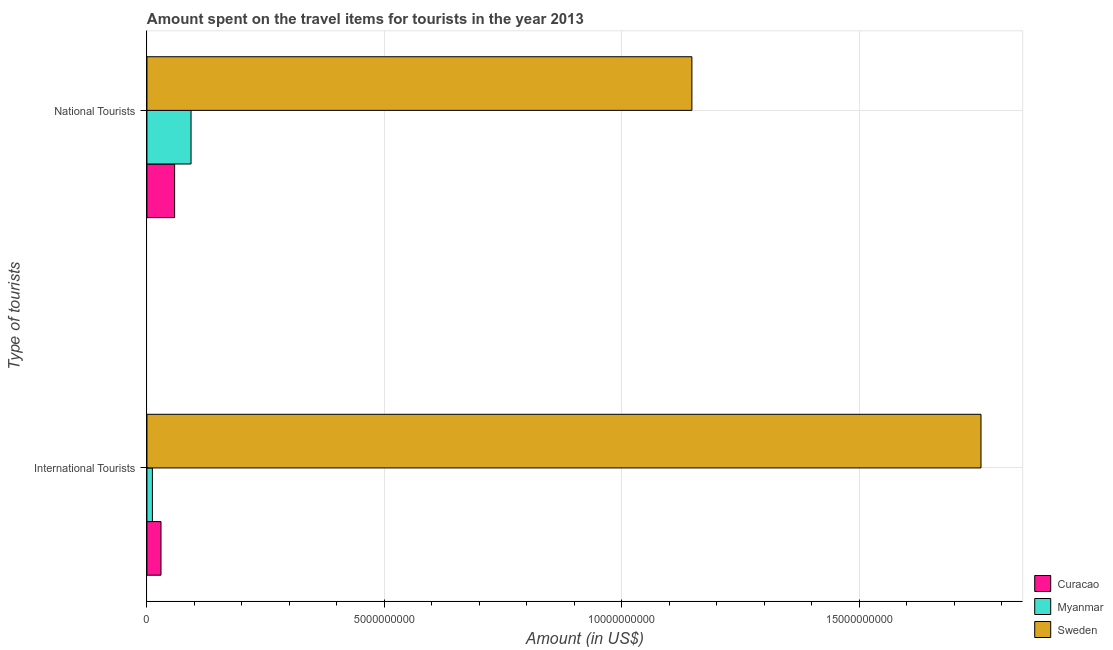How many different coloured bars are there?
Your answer should be compact. 3. Are the number of bars per tick equal to the number of legend labels?
Your answer should be compact. Yes. What is the label of the 1st group of bars from the top?
Keep it short and to the point. National Tourists. What is the amount spent on travel items of international tourists in Myanmar?
Keep it short and to the point. 1.15e+08. Across all countries, what is the maximum amount spent on travel items of international tourists?
Your answer should be very brief. 1.76e+1. Across all countries, what is the minimum amount spent on travel items of national tourists?
Give a very brief answer. 5.83e+08. In which country was the amount spent on travel items of international tourists maximum?
Give a very brief answer. Sweden. In which country was the amount spent on travel items of national tourists minimum?
Offer a terse response. Curacao. What is the total amount spent on travel items of national tourists in the graph?
Offer a terse response. 1.30e+1. What is the difference between the amount spent on travel items of international tourists in Curacao and that in Myanmar?
Give a very brief answer. 1.81e+08. What is the difference between the amount spent on travel items of national tourists in Curacao and the amount spent on travel items of international tourists in Sweden?
Offer a very short reply. -1.70e+1. What is the average amount spent on travel items of national tourists per country?
Your response must be concise. 4.33e+09. What is the difference between the amount spent on travel items of national tourists and amount spent on travel items of international tourists in Curacao?
Provide a succinct answer. 2.87e+08. In how many countries, is the amount spent on travel items of national tourists greater than 4000000000 US$?
Offer a very short reply. 1. What is the ratio of the amount spent on travel items of international tourists in Sweden to that in Myanmar?
Offer a terse response. 152.73. Is the amount spent on travel items of international tourists in Curacao less than that in Myanmar?
Your response must be concise. No. In how many countries, is the amount spent on travel items of national tourists greater than the average amount spent on travel items of national tourists taken over all countries?
Provide a short and direct response. 1. What does the 1st bar from the top in National Tourists represents?
Your response must be concise. Sweden. What does the 1st bar from the bottom in International Tourists represents?
Offer a very short reply. Curacao. Are the values on the major ticks of X-axis written in scientific E-notation?
Ensure brevity in your answer.  No. Does the graph contain any zero values?
Your answer should be very brief. No. Does the graph contain grids?
Ensure brevity in your answer.  Yes. Where does the legend appear in the graph?
Make the answer very short. Bottom right. How many legend labels are there?
Make the answer very short. 3. What is the title of the graph?
Keep it short and to the point. Amount spent on the travel items for tourists in the year 2013. Does "Small states" appear as one of the legend labels in the graph?
Give a very brief answer. No. What is the label or title of the X-axis?
Offer a very short reply. Amount (in US$). What is the label or title of the Y-axis?
Provide a succinct answer. Type of tourists. What is the Amount (in US$) of Curacao in International Tourists?
Keep it short and to the point. 2.96e+08. What is the Amount (in US$) in Myanmar in International Tourists?
Keep it short and to the point. 1.15e+08. What is the Amount (in US$) of Sweden in International Tourists?
Offer a very short reply. 1.76e+1. What is the Amount (in US$) in Curacao in National Tourists?
Provide a succinct answer. 5.83e+08. What is the Amount (in US$) in Myanmar in National Tourists?
Provide a short and direct response. 9.29e+08. What is the Amount (in US$) of Sweden in National Tourists?
Your answer should be very brief. 1.15e+1. Across all Type of tourists, what is the maximum Amount (in US$) in Curacao?
Provide a succinct answer. 5.83e+08. Across all Type of tourists, what is the maximum Amount (in US$) of Myanmar?
Ensure brevity in your answer.  9.29e+08. Across all Type of tourists, what is the maximum Amount (in US$) of Sweden?
Your answer should be very brief. 1.76e+1. Across all Type of tourists, what is the minimum Amount (in US$) in Curacao?
Provide a short and direct response. 2.96e+08. Across all Type of tourists, what is the minimum Amount (in US$) of Myanmar?
Offer a terse response. 1.15e+08. Across all Type of tourists, what is the minimum Amount (in US$) in Sweden?
Keep it short and to the point. 1.15e+1. What is the total Amount (in US$) in Curacao in the graph?
Provide a short and direct response. 8.79e+08. What is the total Amount (in US$) in Myanmar in the graph?
Give a very brief answer. 1.04e+09. What is the total Amount (in US$) of Sweden in the graph?
Provide a short and direct response. 2.90e+1. What is the difference between the Amount (in US$) of Curacao in International Tourists and that in National Tourists?
Provide a short and direct response. -2.87e+08. What is the difference between the Amount (in US$) of Myanmar in International Tourists and that in National Tourists?
Offer a very short reply. -8.14e+08. What is the difference between the Amount (in US$) in Sweden in International Tourists and that in National Tourists?
Offer a terse response. 6.09e+09. What is the difference between the Amount (in US$) in Curacao in International Tourists and the Amount (in US$) in Myanmar in National Tourists?
Your response must be concise. -6.33e+08. What is the difference between the Amount (in US$) of Curacao in International Tourists and the Amount (in US$) of Sweden in National Tourists?
Ensure brevity in your answer.  -1.12e+1. What is the difference between the Amount (in US$) in Myanmar in International Tourists and the Amount (in US$) in Sweden in National Tourists?
Offer a very short reply. -1.14e+1. What is the average Amount (in US$) of Curacao per Type of tourists?
Give a very brief answer. 4.40e+08. What is the average Amount (in US$) of Myanmar per Type of tourists?
Give a very brief answer. 5.22e+08. What is the average Amount (in US$) of Sweden per Type of tourists?
Give a very brief answer. 1.45e+1. What is the difference between the Amount (in US$) in Curacao and Amount (in US$) in Myanmar in International Tourists?
Your answer should be compact. 1.81e+08. What is the difference between the Amount (in US$) of Curacao and Amount (in US$) of Sweden in International Tourists?
Make the answer very short. -1.73e+1. What is the difference between the Amount (in US$) in Myanmar and Amount (in US$) in Sweden in International Tourists?
Your response must be concise. -1.74e+1. What is the difference between the Amount (in US$) of Curacao and Amount (in US$) of Myanmar in National Tourists?
Your answer should be compact. -3.46e+08. What is the difference between the Amount (in US$) in Curacao and Amount (in US$) in Sweden in National Tourists?
Your response must be concise. -1.09e+1. What is the difference between the Amount (in US$) of Myanmar and Amount (in US$) of Sweden in National Tourists?
Give a very brief answer. -1.05e+1. What is the ratio of the Amount (in US$) of Curacao in International Tourists to that in National Tourists?
Your answer should be very brief. 0.51. What is the ratio of the Amount (in US$) of Myanmar in International Tourists to that in National Tourists?
Offer a very short reply. 0.12. What is the ratio of the Amount (in US$) in Sweden in International Tourists to that in National Tourists?
Make the answer very short. 1.53. What is the difference between the highest and the second highest Amount (in US$) of Curacao?
Your answer should be compact. 2.87e+08. What is the difference between the highest and the second highest Amount (in US$) of Myanmar?
Ensure brevity in your answer.  8.14e+08. What is the difference between the highest and the second highest Amount (in US$) of Sweden?
Keep it short and to the point. 6.09e+09. What is the difference between the highest and the lowest Amount (in US$) in Curacao?
Give a very brief answer. 2.87e+08. What is the difference between the highest and the lowest Amount (in US$) in Myanmar?
Keep it short and to the point. 8.14e+08. What is the difference between the highest and the lowest Amount (in US$) in Sweden?
Your response must be concise. 6.09e+09. 